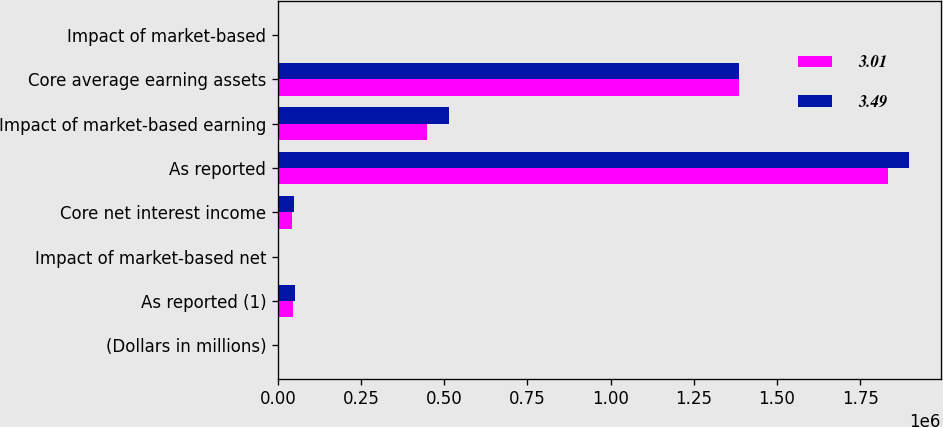Convert chart to OTSL. <chart><loc_0><loc_0><loc_500><loc_500><stacked_bar_chart><ecel><fcel>(Dollars in millions)<fcel>As reported (1)<fcel>Impact of market-based net<fcel>Core net interest income<fcel>As reported<fcel>Impact of market-based earning<fcel>Core average earning assets<fcel>Impact of market-based<nl><fcel>3.01<fcel>2011<fcel>45588<fcel>3813<fcel>41775<fcel>1.83466e+06<fcel>448776<fcel>1.38588e+06<fcel>0.53<nl><fcel>3.49<fcel>2010<fcel>52693<fcel>4430<fcel>48263<fcel>1.89757e+06<fcel>512804<fcel>1.38477e+06<fcel>0.71<nl></chart> 